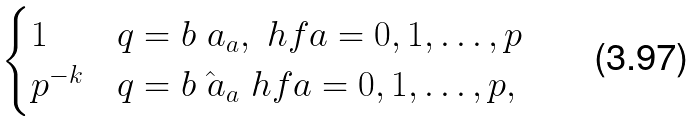Convert formula to latex. <formula><loc_0><loc_0><loc_500><loc_500>\begin{cases} 1 & q = b \ a _ { a } , \ h f a = 0 , 1 , \dots , p \\ p ^ { - k } & q = b \hat { \ a } _ { a } \ h f a = 0 , 1 , \dots , p , \end{cases}</formula> 